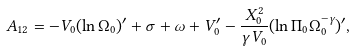<formula> <loc_0><loc_0><loc_500><loc_500>A _ { 1 2 } = - V _ { 0 } ( \ln \Omega _ { 0 } ) ^ { \prime } + \sigma + \omega + V _ { 0 } ^ { \prime } - \frac { X _ { 0 } ^ { 2 } } { \gamma V _ { 0 } } ( \ln \Pi _ { 0 } \Omega _ { 0 } ^ { - \gamma } ) ^ { \prime } ,</formula> 